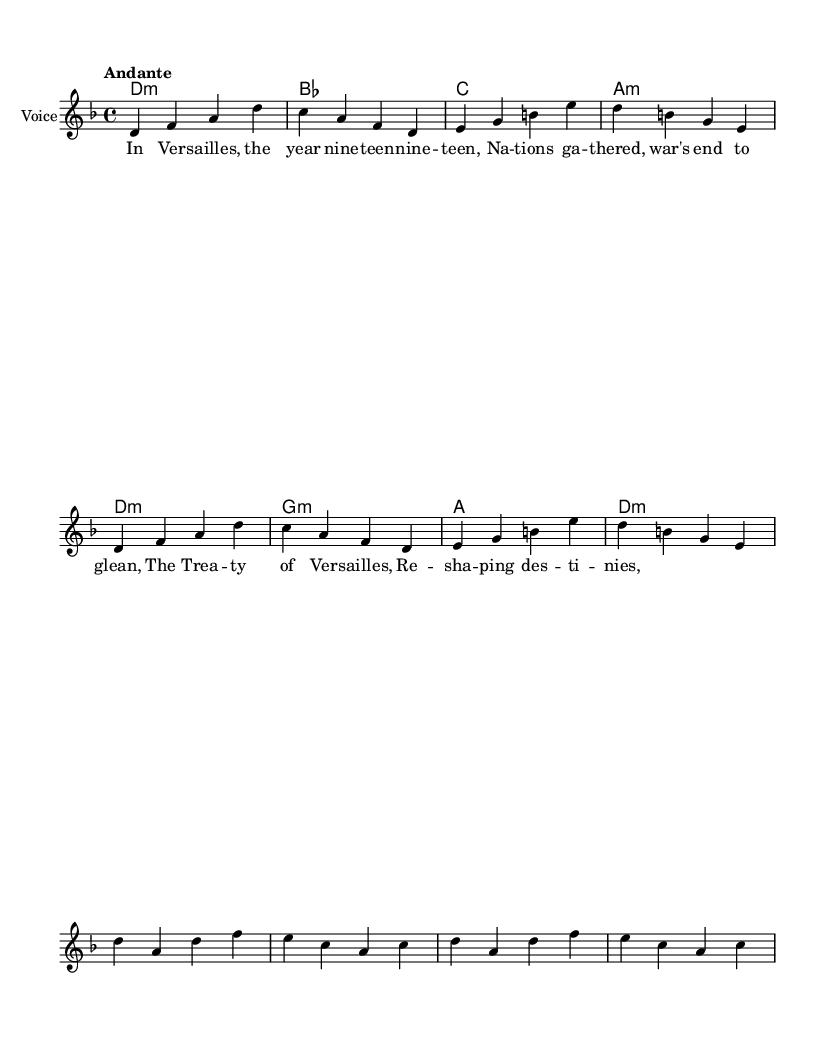What is the key signature of this music? The key signature shows B♭ and E♭, indicating that the music is in D minor. This key signature is marked at the beginning of the sheet music.
Answer: D minor What is the time signature of this music? The time signature, indicated at the beginning of the sheet music, is 4/4. This means there are four beats in each measure, and the quarter note gets one beat.
Answer: 4/4 What is the tempo marking for this music? The tempo marking is specified as "Andante," which indicates a moderately slow pace. This term appears at the beginning of the music.
Answer: Andante How many measures are in the verse? The verse section consists of 2 repeated measures, as indicated by the notation in that section of the sheet music. Each measure's contents are counted to get the total.
Answer: 2 measures What is the main theme of the chorus? The chorus repeats the key lyric "The Treaty of Versailles," indicating the central theme is focused on this historical event. This phrase is highlighted in the lyrics.
Answer: The Treaty of Versailles How many parts are in the score? The score contains three distinct parts: Chord Names, Voice, and Lyrics. Each part serves a different musical function and is indicated by its specific notation in the layout.
Answer: 3 parts What year is significant in the lyrics associated with this music? The lyrics reference the year "nineteen-nineteen," marking the end of World War I and the signing of the Treaty of Versailles, a pivotal moment in world history. This year is directly mentioned in the verse.
Answer: nineteen-nineteen 